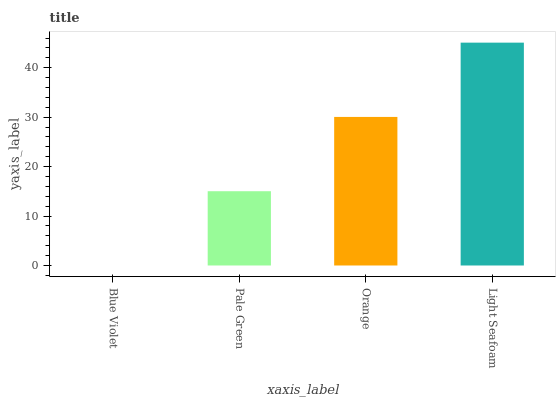Is Pale Green the minimum?
Answer yes or no. No. Is Pale Green the maximum?
Answer yes or no. No. Is Pale Green greater than Blue Violet?
Answer yes or no. Yes. Is Blue Violet less than Pale Green?
Answer yes or no. Yes. Is Blue Violet greater than Pale Green?
Answer yes or no. No. Is Pale Green less than Blue Violet?
Answer yes or no. No. Is Orange the high median?
Answer yes or no. Yes. Is Pale Green the low median?
Answer yes or no. Yes. Is Pale Green the high median?
Answer yes or no. No. Is Blue Violet the low median?
Answer yes or no. No. 